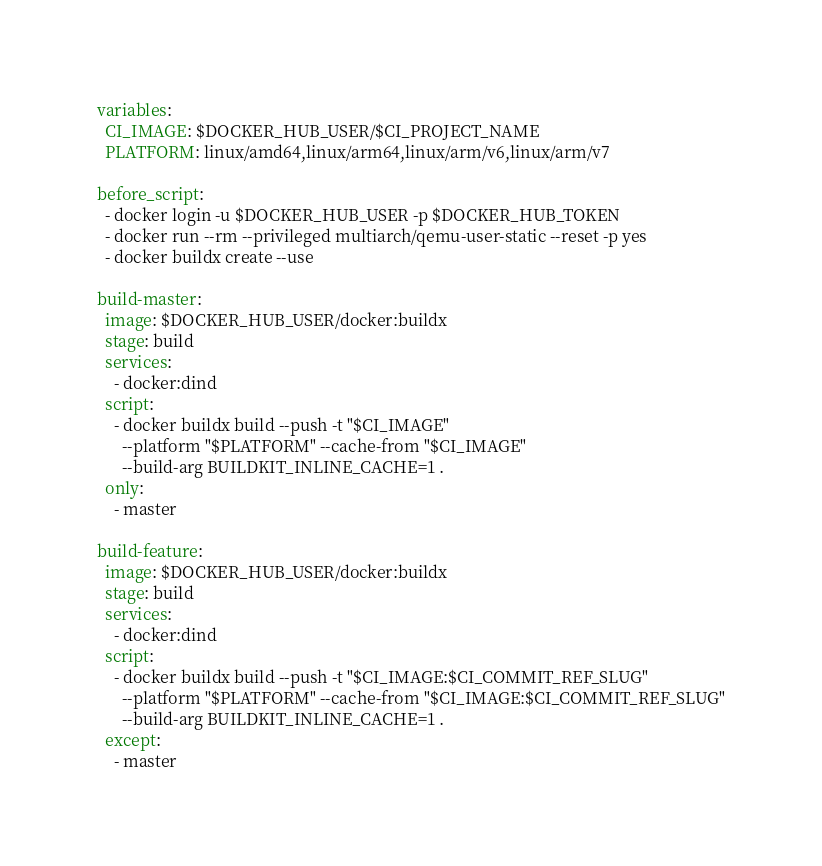Convert code to text. <code><loc_0><loc_0><loc_500><loc_500><_YAML_>variables:
  CI_IMAGE: $DOCKER_HUB_USER/$CI_PROJECT_NAME
  PLATFORM: linux/amd64,linux/arm64,linux/arm/v6,linux/arm/v7

before_script:
  - docker login -u $DOCKER_HUB_USER -p $DOCKER_HUB_TOKEN
  - docker run --rm --privileged multiarch/qemu-user-static --reset -p yes
  - docker buildx create --use

build-master:
  image: $DOCKER_HUB_USER/docker:buildx
  stage: build
  services:
    - docker:dind
  script:
    - docker buildx build --push -t "$CI_IMAGE"
      --platform "$PLATFORM" --cache-from "$CI_IMAGE"
      --build-arg BUILDKIT_INLINE_CACHE=1 .
  only:
    - master

build-feature:
  image: $DOCKER_HUB_USER/docker:buildx
  stage: build
  services:
    - docker:dind
  script:
    - docker buildx build --push -t "$CI_IMAGE:$CI_COMMIT_REF_SLUG" 
      --platform "$PLATFORM" --cache-from "$CI_IMAGE:$CI_COMMIT_REF_SLUG"
      --build-arg BUILDKIT_INLINE_CACHE=1 .
  except:
    - master
</code> 